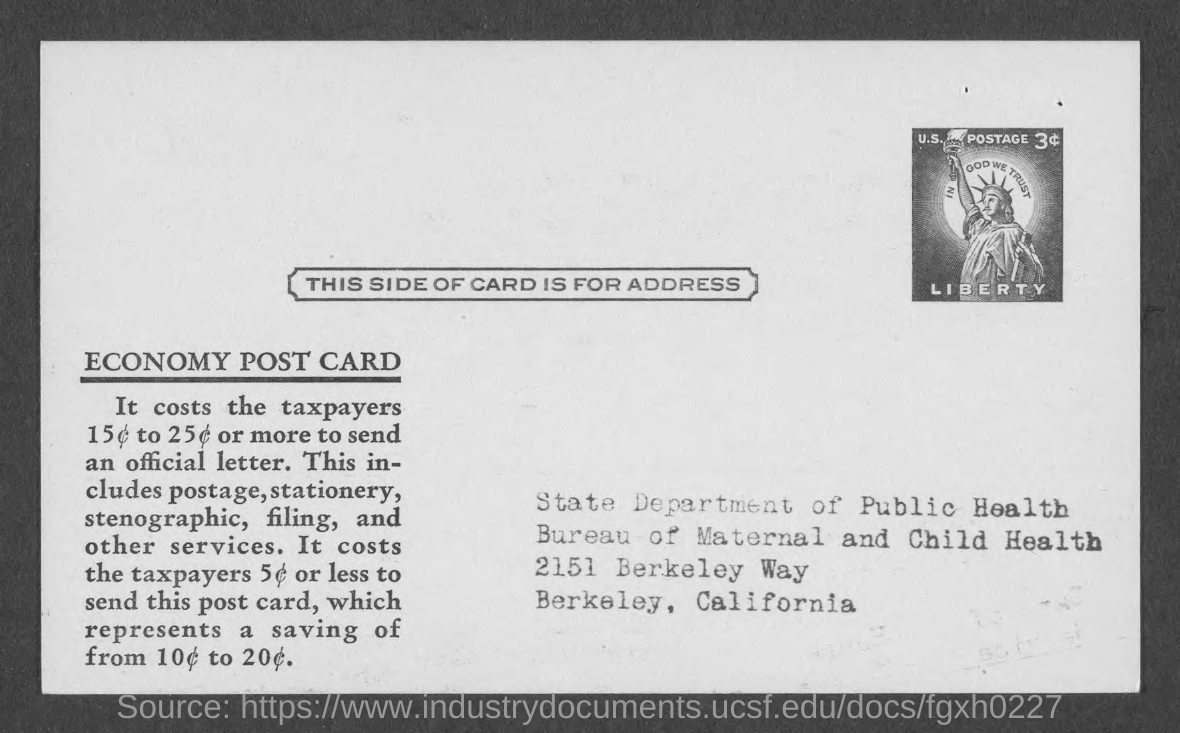Which department is mentioned in the address given?
Make the answer very short. State Department of Public Health. 